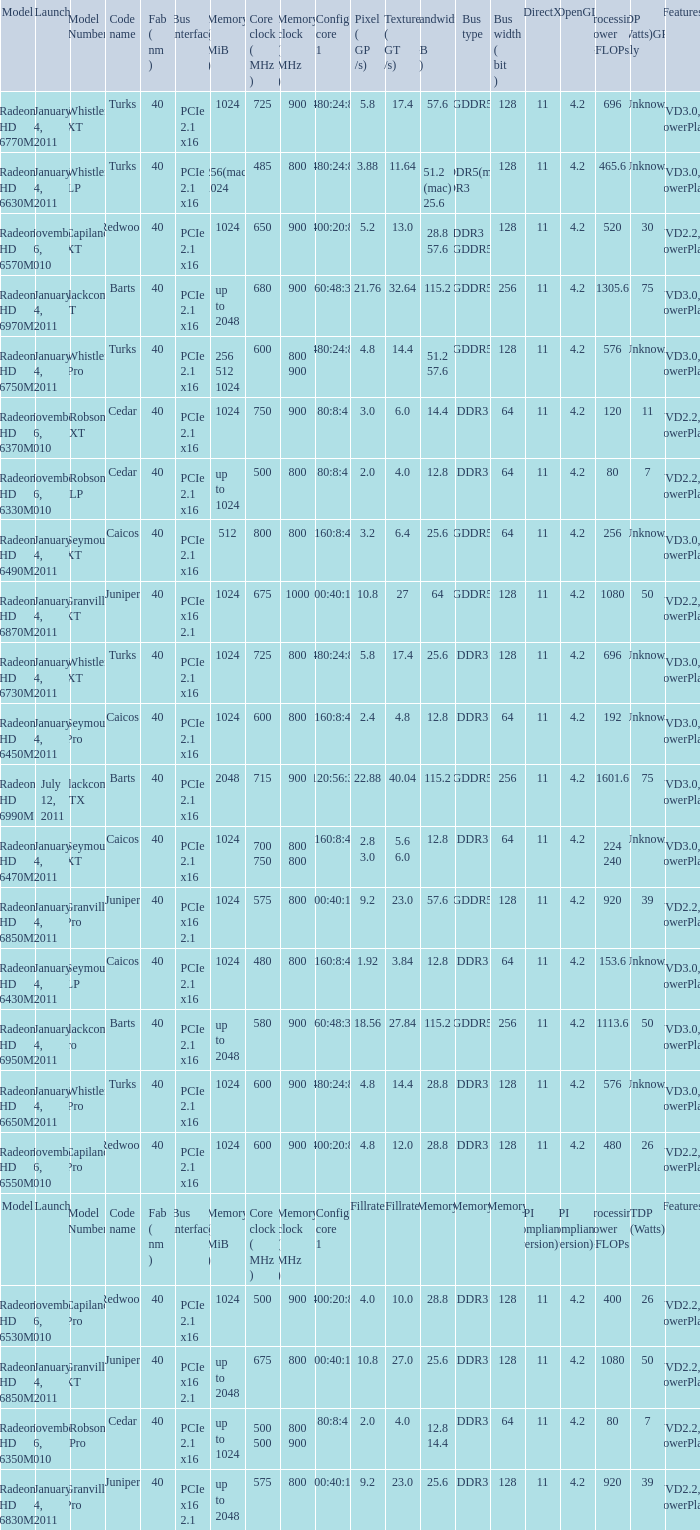What is every code name for the model Radeon HD 6650m? Turks. 